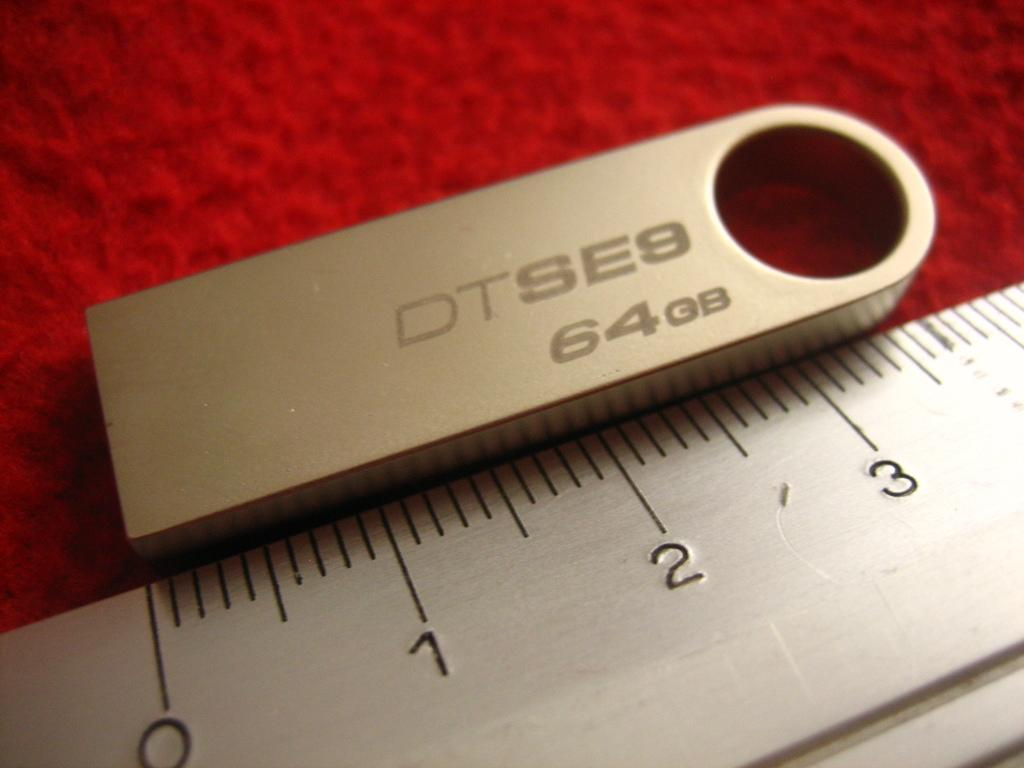<image>
Give a short and clear explanation of the subsequent image. A metallic ruler measuring a silver 64 gigabyte usb stick on a red background. 